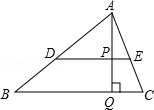Could you explore the potential applications of the Pythagorean theorem in this diagram? Certainly! The Pythagorean theorem can be applied in triangle APQ, as it is a right triangle. Given the lengths of any two sides of this triangle, one can calculate the third side using the theorem. Furthermore, if we consider triangle ADE, having some side lengths, it might also be possible to explore Pythagorean relations, assuming right angles could be present or formed. How would you verify that triangle ADE could be a right triangle? To verify triangle ADE as a right triangle, measurement or construction would be required to identify whether angle ADE or angle DEA is a right angle. If either is 90 degrees, applying the Pythagorean theorem would confirm it. Without given measurements, one needs to use construction properties and the axioms or theorems of geometry relevant to angle formation and side relations. 